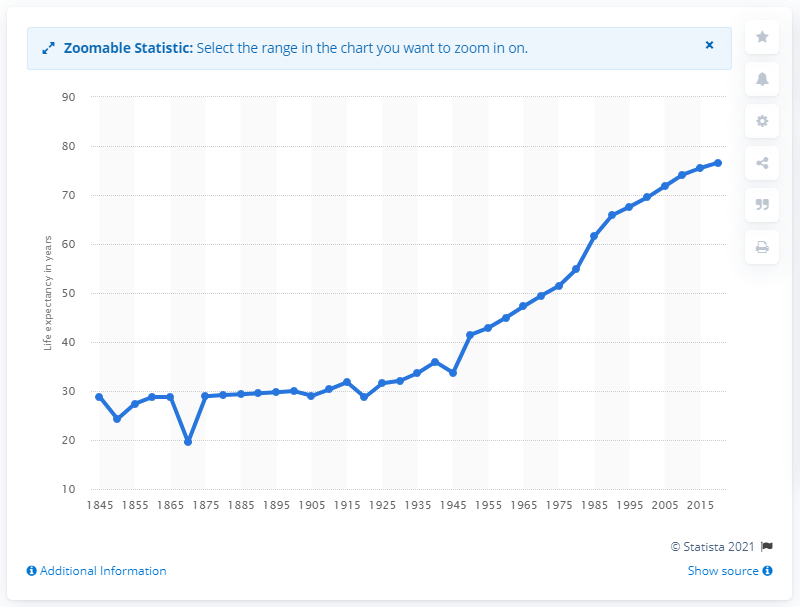Indicate a few pertinent items in this graphic. In the year 2020, Algeria's life expectancy was more than double what it was before the Second World War. 